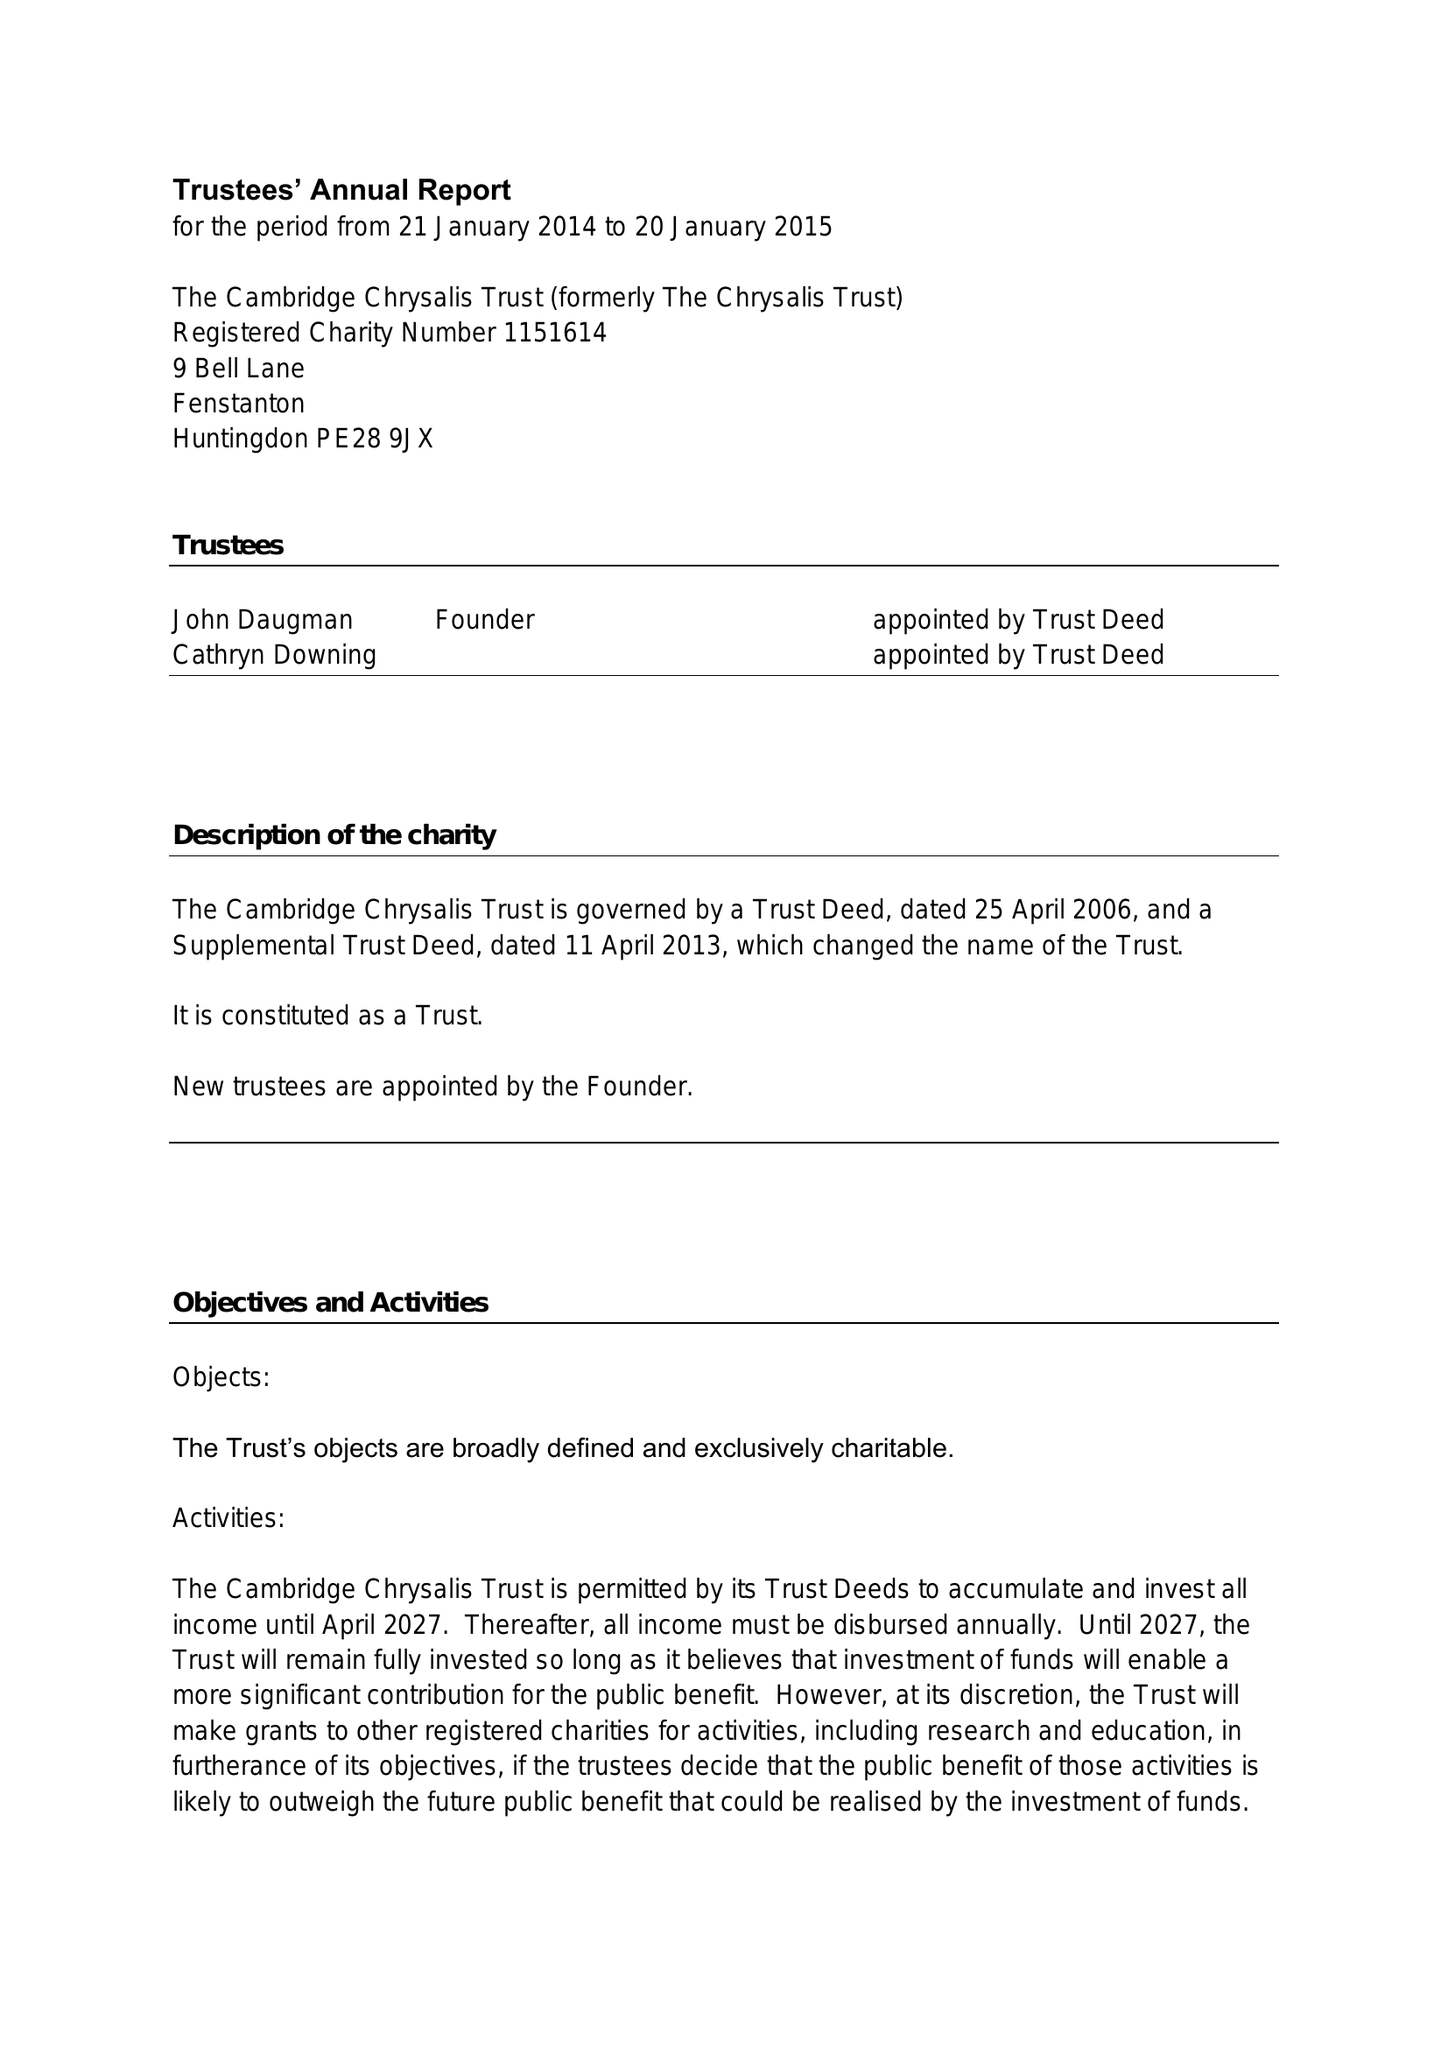What is the value for the income_annually_in_british_pounds?
Answer the question using a single word or phrase. 68478.00 